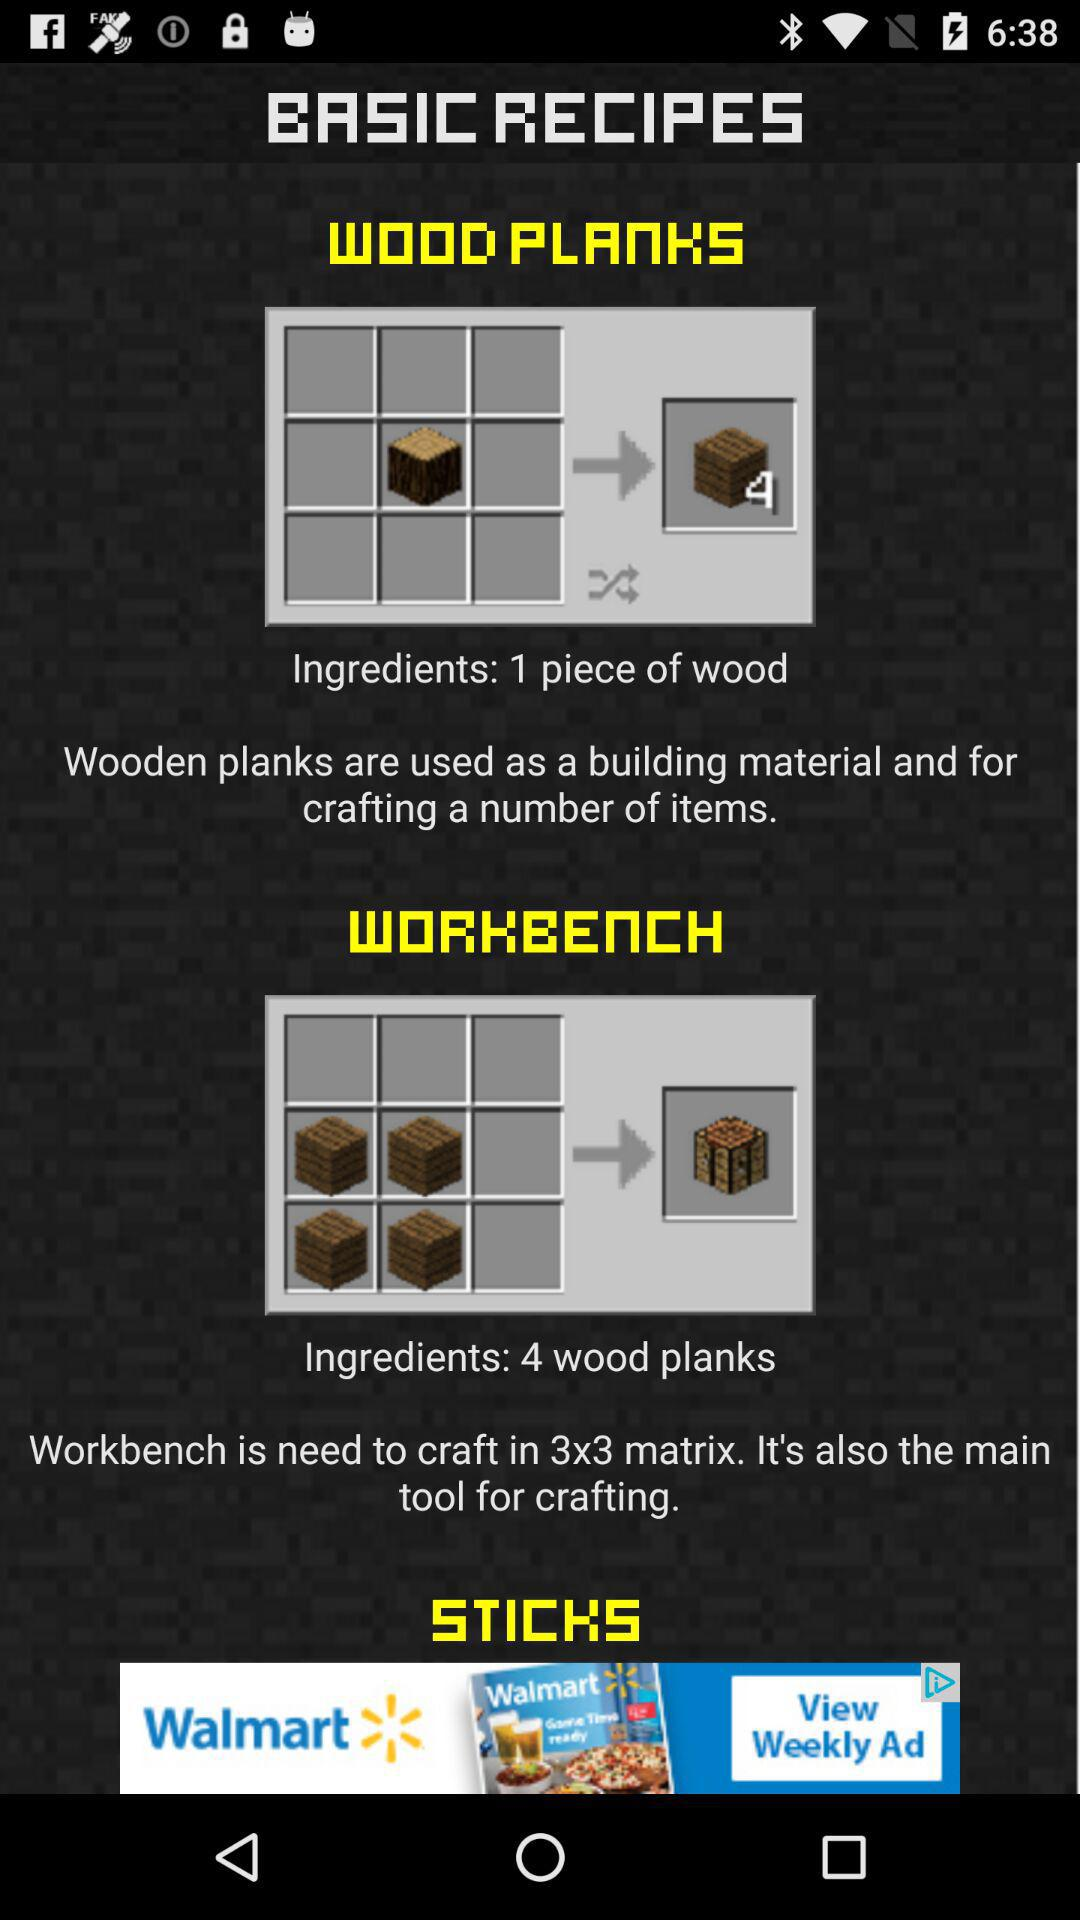What are the ingredients for "WOOD PLANKS"? The ingredient is a piece of wood. 